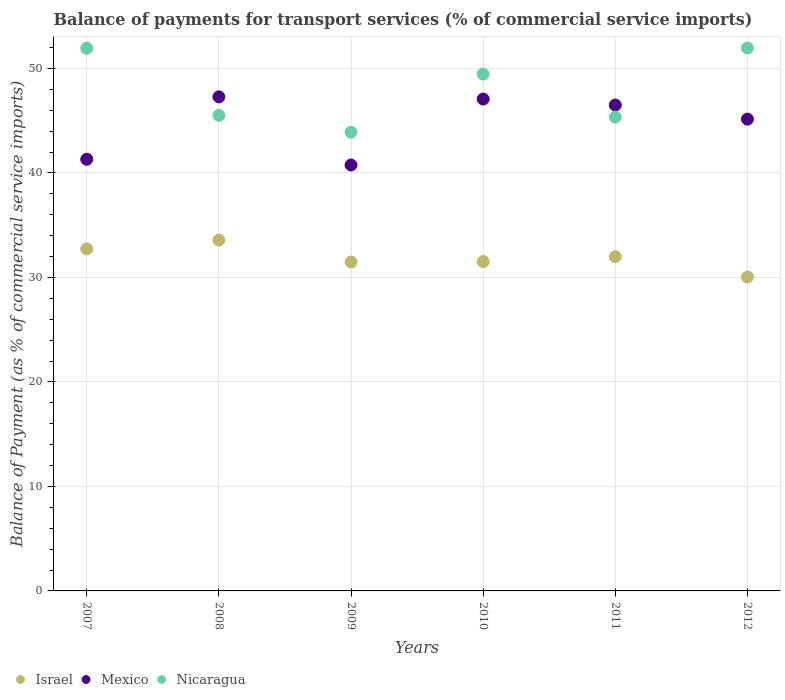What is the balance of payments for transport services in Nicaragua in 2008?
Give a very brief answer. 45.51. Across all years, what is the maximum balance of payments for transport services in Nicaragua?
Keep it short and to the point. 51.96. Across all years, what is the minimum balance of payments for transport services in Mexico?
Your answer should be very brief. 40.76. What is the total balance of payments for transport services in Nicaragua in the graph?
Offer a very short reply. 288.12. What is the difference between the balance of payments for transport services in Nicaragua in 2008 and that in 2012?
Give a very brief answer. -6.45. What is the difference between the balance of payments for transport services in Nicaragua in 2009 and the balance of payments for transport services in Israel in 2010?
Offer a terse response. 12.38. What is the average balance of payments for transport services in Nicaragua per year?
Your answer should be very brief. 48.02. In the year 2008, what is the difference between the balance of payments for transport services in Israel and balance of payments for transport services in Mexico?
Your answer should be compact. -13.71. What is the ratio of the balance of payments for transport services in Mexico in 2011 to that in 2012?
Offer a terse response. 1.03. Is the balance of payments for transport services in Mexico in 2007 less than that in 2012?
Your answer should be very brief. Yes. What is the difference between the highest and the second highest balance of payments for transport services in Nicaragua?
Make the answer very short. 0.03. What is the difference between the highest and the lowest balance of payments for transport services in Israel?
Make the answer very short. 3.53. Is it the case that in every year, the sum of the balance of payments for transport services in Israel and balance of payments for transport services in Mexico  is greater than the balance of payments for transport services in Nicaragua?
Offer a very short reply. Yes. Does the balance of payments for transport services in Nicaragua monotonically increase over the years?
Your response must be concise. No. Is the balance of payments for transport services in Mexico strictly greater than the balance of payments for transport services in Nicaragua over the years?
Make the answer very short. No. Is the balance of payments for transport services in Mexico strictly less than the balance of payments for transport services in Israel over the years?
Offer a terse response. No. How many dotlines are there?
Offer a terse response. 3. How many years are there in the graph?
Keep it short and to the point. 6. Where does the legend appear in the graph?
Offer a very short reply. Bottom left. What is the title of the graph?
Offer a very short reply. Balance of payments for transport services (% of commercial service imports). What is the label or title of the X-axis?
Offer a very short reply. Years. What is the label or title of the Y-axis?
Your response must be concise. Balance of Payment (as % of commercial service imports). What is the Balance of Payment (as % of commercial service imports) in Israel in 2007?
Provide a short and direct response. 32.74. What is the Balance of Payment (as % of commercial service imports) of Mexico in 2007?
Offer a terse response. 41.31. What is the Balance of Payment (as % of commercial service imports) of Nicaragua in 2007?
Your answer should be very brief. 51.93. What is the Balance of Payment (as % of commercial service imports) in Israel in 2008?
Provide a short and direct response. 33.58. What is the Balance of Payment (as % of commercial service imports) in Mexico in 2008?
Offer a terse response. 47.29. What is the Balance of Payment (as % of commercial service imports) of Nicaragua in 2008?
Make the answer very short. 45.51. What is the Balance of Payment (as % of commercial service imports) of Israel in 2009?
Your answer should be very brief. 31.48. What is the Balance of Payment (as % of commercial service imports) of Mexico in 2009?
Your answer should be very brief. 40.76. What is the Balance of Payment (as % of commercial service imports) in Nicaragua in 2009?
Offer a terse response. 43.9. What is the Balance of Payment (as % of commercial service imports) of Israel in 2010?
Keep it short and to the point. 31.52. What is the Balance of Payment (as % of commercial service imports) of Mexico in 2010?
Provide a succinct answer. 47.08. What is the Balance of Payment (as % of commercial service imports) in Nicaragua in 2010?
Offer a very short reply. 49.46. What is the Balance of Payment (as % of commercial service imports) in Israel in 2011?
Your response must be concise. 31.99. What is the Balance of Payment (as % of commercial service imports) of Mexico in 2011?
Keep it short and to the point. 46.5. What is the Balance of Payment (as % of commercial service imports) in Nicaragua in 2011?
Give a very brief answer. 45.35. What is the Balance of Payment (as % of commercial service imports) in Israel in 2012?
Make the answer very short. 30.04. What is the Balance of Payment (as % of commercial service imports) of Mexico in 2012?
Your answer should be very brief. 45.15. What is the Balance of Payment (as % of commercial service imports) of Nicaragua in 2012?
Ensure brevity in your answer.  51.96. Across all years, what is the maximum Balance of Payment (as % of commercial service imports) in Israel?
Provide a short and direct response. 33.58. Across all years, what is the maximum Balance of Payment (as % of commercial service imports) in Mexico?
Give a very brief answer. 47.29. Across all years, what is the maximum Balance of Payment (as % of commercial service imports) in Nicaragua?
Ensure brevity in your answer.  51.96. Across all years, what is the minimum Balance of Payment (as % of commercial service imports) in Israel?
Your answer should be very brief. 30.04. Across all years, what is the minimum Balance of Payment (as % of commercial service imports) of Mexico?
Your answer should be very brief. 40.76. Across all years, what is the minimum Balance of Payment (as % of commercial service imports) in Nicaragua?
Your answer should be compact. 43.9. What is the total Balance of Payment (as % of commercial service imports) of Israel in the graph?
Keep it short and to the point. 191.35. What is the total Balance of Payment (as % of commercial service imports) of Mexico in the graph?
Offer a very short reply. 268.1. What is the total Balance of Payment (as % of commercial service imports) of Nicaragua in the graph?
Provide a short and direct response. 288.12. What is the difference between the Balance of Payment (as % of commercial service imports) of Israel in 2007 and that in 2008?
Provide a short and direct response. -0.84. What is the difference between the Balance of Payment (as % of commercial service imports) of Mexico in 2007 and that in 2008?
Make the answer very short. -5.98. What is the difference between the Balance of Payment (as % of commercial service imports) in Nicaragua in 2007 and that in 2008?
Provide a short and direct response. 6.42. What is the difference between the Balance of Payment (as % of commercial service imports) of Israel in 2007 and that in 2009?
Offer a terse response. 1.26. What is the difference between the Balance of Payment (as % of commercial service imports) of Mexico in 2007 and that in 2009?
Offer a very short reply. 0.55. What is the difference between the Balance of Payment (as % of commercial service imports) in Nicaragua in 2007 and that in 2009?
Your answer should be very brief. 8.03. What is the difference between the Balance of Payment (as % of commercial service imports) in Israel in 2007 and that in 2010?
Provide a short and direct response. 1.22. What is the difference between the Balance of Payment (as % of commercial service imports) in Mexico in 2007 and that in 2010?
Your answer should be compact. -5.76. What is the difference between the Balance of Payment (as % of commercial service imports) of Nicaragua in 2007 and that in 2010?
Provide a short and direct response. 2.47. What is the difference between the Balance of Payment (as % of commercial service imports) of Israel in 2007 and that in 2011?
Make the answer very short. 0.75. What is the difference between the Balance of Payment (as % of commercial service imports) of Mexico in 2007 and that in 2011?
Offer a terse response. -5.19. What is the difference between the Balance of Payment (as % of commercial service imports) of Nicaragua in 2007 and that in 2011?
Give a very brief answer. 6.58. What is the difference between the Balance of Payment (as % of commercial service imports) of Israel in 2007 and that in 2012?
Offer a very short reply. 2.69. What is the difference between the Balance of Payment (as % of commercial service imports) of Mexico in 2007 and that in 2012?
Ensure brevity in your answer.  -3.84. What is the difference between the Balance of Payment (as % of commercial service imports) of Nicaragua in 2007 and that in 2012?
Make the answer very short. -0.03. What is the difference between the Balance of Payment (as % of commercial service imports) of Israel in 2008 and that in 2009?
Your answer should be very brief. 2.1. What is the difference between the Balance of Payment (as % of commercial service imports) of Mexico in 2008 and that in 2009?
Give a very brief answer. 6.52. What is the difference between the Balance of Payment (as % of commercial service imports) of Nicaragua in 2008 and that in 2009?
Ensure brevity in your answer.  1.62. What is the difference between the Balance of Payment (as % of commercial service imports) in Israel in 2008 and that in 2010?
Provide a succinct answer. 2.06. What is the difference between the Balance of Payment (as % of commercial service imports) in Mexico in 2008 and that in 2010?
Offer a very short reply. 0.21. What is the difference between the Balance of Payment (as % of commercial service imports) in Nicaragua in 2008 and that in 2010?
Your answer should be very brief. -3.95. What is the difference between the Balance of Payment (as % of commercial service imports) of Israel in 2008 and that in 2011?
Offer a very short reply. 1.59. What is the difference between the Balance of Payment (as % of commercial service imports) of Mexico in 2008 and that in 2011?
Give a very brief answer. 0.78. What is the difference between the Balance of Payment (as % of commercial service imports) of Nicaragua in 2008 and that in 2011?
Ensure brevity in your answer.  0.16. What is the difference between the Balance of Payment (as % of commercial service imports) in Israel in 2008 and that in 2012?
Your answer should be very brief. 3.53. What is the difference between the Balance of Payment (as % of commercial service imports) of Mexico in 2008 and that in 2012?
Your answer should be compact. 2.13. What is the difference between the Balance of Payment (as % of commercial service imports) in Nicaragua in 2008 and that in 2012?
Your answer should be very brief. -6.45. What is the difference between the Balance of Payment (as % of commercial service imports) of Israel in 2009 and that in 2010?
Your response must be concise. -0.04. What is the difference between the Balance of Payment (as % of commercial service imports) in Mexico in 2009 and that in 2010?
Your response must be concise. -6.31. What is the difference between the Balance of Payment (as % of commercial service imports) in Nicaragua in 2009 and that in 2010?
Offer a terse response. -5.57. What is the difference between the Balance of Payment (as % of commercial service imports) in Israel in 2009 and that in 2011?
Keep it short and to the point. -0.51. What is the difference between the Balance of Payment (as % of commercial service imports) in Mexico in 2009 and that in 2011?
Offer a very short reply. -5.74. What is the difference between the Balance of Payment (as % of commercial service imports) in Nicaragua in 2009 and that in 2011?
Your response must be concise. -1.45. What is the difference between the Balance of Payment (as % of commercial service imports) in Israel in 2009 and that in 2012?
Offer a terse response. 1.43. What is the difference between the Balance of Payment (as % of commercial service imports) of Mexico in 2009 and that in 2012?
Make the answer very short. -4.39. What is the difference between the Balance of Payment (as % of commercial service imports) of Nicaragua in 2009 and that in 2012?
Your answer should be compact. -8.06. What is the difference between the Balance of Payment (as % of commercial service imports) of Israel in 2010 and that in 2011?
Your answer should be very brief. -0.47. What is the difference between the Balance of Payment (as % of commercial service imports) in Mexico in 2010 and that in 2011?
Ensure brevity in your answer.  0.57. What is the difference between the Balance of Payment (as % of commercial service imports) of Nicaragua in 2010 and that in 2011?
Your answer should be compact. 4.11. What is the difference between the Balance of Payment (as % of commercial service imports) of Israel in 2010 and that in 2012?
Your response must be concise. 1.48. What is the difference between the Balance of Payment (as % of commercial service imports) in Mexico in 2010 and that in 2012?
Your answer should be very brief. 1.92. What is the difference between the Balance of Payment (as % of commercial service imports) in Nicaragua in 2010 and that in 2012?
Make the answer very short. -2.5. What is the difference between the Balance of Payment (as % of commercial service imports) of Israel in 2011 and that in 2012?
Keep it short and to the point. 1.95. What is the difference between the Balance of Payment (as % of commercial service imports) of Mexico in 2011 and that in 2012?
Provide a short and direct response. 1.35. What is the difference between the Balance of Payment (as % of commercial service imports) in Nicaragua in 2011 and that in 2012?
Your answer should be compact. -6.61. What is the difference between the Balance of Payment (as % of commercial service imports) of Israel in 2007 and the Balance of Payment (as % of commercial service imports) of Mexico in 2008?
Your answer should be compact. -14.55. What is the difference between the Balance of Payment (as % of commercial service imports) of Israel in 2007 and the Balance of Payment (as % of commercial service imports) of Nicaragua in 2008?
Offer a very short reply. -12.77. What is the difference between the Balance of Payment (as % of commercial service imports) of Mexico in 2007 and the Balance of Payment (as % of commercial service imports) of Nicaragua in 2008?
Your response must be concise. -4.2. What is the difference between the Balance of Payment (as % of commercial service imports) of Israel in 2007 and the Balance of Payment (as % of commercial service imports) of Mexico in 2009?
Provide a short and direct response. -8.02. What is the difference between the Balance of Payment (as % of commercial service imports) of Israel in 2007 and the Balance of Payment (as % of commercial service imports) of Nicaragua in 2009?
Your answer should be very brief. -11.16. What is the difference between the Balance of Payment (as % of commercial service imports) of Mexico in 2007 and the Balance of Payment (as % of commercial service imports) of Nicaragua in 2009?
Your answer should be very brief. -2.59. What is the difference between the Balance of Payment (as % of commercial service imports) of Israel in 2007 and the Balance of Payment (as % of commercial service imports) of Mexico in 2010?
Offer a terse response. -14.34. What is the difference between the Balance of Payment (as % of commercial service imports) of Israel in 2007 and the Balance of Payment (as % of commercial service imports) of Nicaragua in 2010?
Offer a very short reply. -16.72. What is the difference between the Balance of Payment (as % of commercial service imports) in Mexico in 2007 and the Balance of Payment (as % of commercial service imports) in Nicaragua in 2010?
Provide a succinct answer. -8.15. What is the difference between the Balance of Payment (as % of commercial service imports) of Israel in 2007 and the Balance of Payment (as % of commercial service imports) of Mexico in 2011?
Offer a very short reply. -13.76. What is the difference between the Balance of Payment (as % of commercial service imports) in Israel in 2007 and the Balance of Payment (as % of commercial service imports) in Nicaragua in 2011?
Keep it short and to the point. -12.61. What is the difference between the Balance of Payment (as % of commercial service imports) in Mexico in 2007 and the Balance of Payment (as % of commercial service imports) in Nicaragua in 2011?
Your response must be concise. -4.04. What is the difference between the Balance of Payment (as % of commercial service imports) of Israel in 2007 and the Balance of Payment (as % of commercial service imports) of Mexico in 2012?
Your answer should be compact. -12.41. What is the difference between the Balance of Payment (as % of commercial service imports) of Israel in 2007 and the Balance of Payment (as % of commercial service imports) of Nicaragua in 2012?
Offer a terse response. -19.22. What is the difference between the Balance of Payment (as % of commercial service imports) in Mexico in 2007 and the Balance of Payment (as % of commercial service imports) in Nicaragua in 2012?
Keep it short and to the point. -10.65. What is the difference between the Balance of Payment (as % of commercial service imports) in Israel in 2008 and the Balance of Payment (as % of commercial service imports) in Mexico in 2009?
Offer a very short reply. -7.19. What is the difference between the Balance of Payment (as % of commercial service imports) of Israel in 2008 and the Balance of Payment (as % of commercial service imports) of Nicaragua in 2009?
Offer a very short reply. -10.32. What is the difference between the Balance of Payment (as % of commercial service imports) in Mexico in 2008 and the Balance of Payment (as % of commercial service imports) in Nicaragua in 2009?
Offer a very short reply. 3.39. What is the difference between the Balance of Payment (as % of commercial service imports) in Israel in 2008 and the Balance of Payment (as % of commercial service imports) in Mexico in 2010?
Ensure brevity in your answer.  -13.5. What is the difference between the Balance of Payment (as % of commercial service imports) of Israel in 2008 and the Balance of Payment (as % of commercial service imports) of Nicaragua in 2010?
Provide a short and direct response. -15.89. What is the difference between the Balance of Payment (as % of commercial service imports) of Mexico in 2008 and the Balance of Payment (as % of commercial service imports) of Nicaragua in 2010?
Keep it short and to the point. -2.18. What is the difference between the Balance of Payment (as % of commercial service imports) of Israel in 2008 and the Balance of Payment (as % of commercial service imports) of Mexico in 2011?
Offer a very short reply. -12.93. What is the difference between the Balance of Payment (as % of commercial service imports) in Israel in 2008 and the Balance of Payment (as % of commercial service imports) in Nicaragua in 2011?
Your answer should be compact. -11.77. What is the difference between the Balance of Payment (as % of commercial service imports) in Mexico in 2008 and the Balance of Payment (as % of commercial service imports) in Nicaragua in 2011?
Provide a short and direct response. 1.94. What is the difference between the Balance of Payment (as % of commercial service imports) of Israel in 2008 and the Balance of Payment (as % of commercial service imports) of Mexico in 2012?
Ensure brevity in your answer.  -11.58. What is the difference between the Balance of Payment (as % of commercial service imports) of Israel in 2008 and the Balance of Payment (as % of commercial service imports) of Nicaragua in 2012?
Provide a succinct answer. -18.38. What is the difference between the Balance of Payment (as % of commercial service imports) of Mexico in 2008 and the Balance of Payment (as % of commercial service imports) of Nicaragua in 2012?
Provide a succinct answer. -4.67. What is the difference between the Balance of Payment (as % of commercial service imports) of Israel in 2009 and the Balance of Payment (as % of commercial service imports) of Mexico in 2010?
Keep it short and to the point. -15.6. What is the difference between the Balance of Payment (as % of commercial service imports) in Israel in 2009 and the Balance of Payment (as % of commercial service imports) in Nicaragua in 2010?
Ensure brevity in your answer.  -17.98. What is the difference between the Balance of Payment (as % of commercial service imports) of Mexico in 2009 and the Balance of Payment (as % of commercial service imports) of Nicaragua in 2010?
Your response must be concise. -8.7. What is the difference between the Balance of Payment (as % of commercial service imports) of Israel in 2009 and the Balance of Payment (as % of commercial service imports) of Mexico in 2011?
Offer a very short reply. -15.02. What is the difference between the Balance of Payment (as % of commercial service imports) in Israel in 2009 and the Balance of Payment (as % of commercial service imports) in Nicaragua in 2011?
Keep it short and to the point. -13.87. What is the difference between the Balance of Payment (as % of commercial service imports) in Mexico in 2009 and the Balance of Payment (as % of commercial service imports) in Nicaragua in 2011?
Provide a short and direct response. -4.59. What is the difference between the Balance of Payment (as % of commercial service imports) of Israel in 2009 and the Balance of Payment (as % of commercial service imports) of Mexico in 2012?
Offer a terse response. -13.67. What is the difference between the Balance of Payment (as % of commercial service imports) in Israel in 2009 and the Balance of Payment (as % of commercial service imports) in Nicaragua in 2012?
Offer a very short reply. -20.48. What is the difference between the Balance of Payment (as % of commercial service imports) of Mexico in 2009 and the Balance of Payment (as % of commercial service imports) of Nicaragua in 2012?
Provide a succinct answer. -11.2. What is the difference between the Balance of Payment (as % of commercial service imports) of Israel in 2010 and the Balance of Payment (as % of commercial service imports) of Mexico in 2011?
Offer a very short reply. -14.98. What is the difference between the Balance of Payment (as % of commercial service imports) of Israel in 2010 and the Balance of Payment (as % of commercial service imports) of Nicaragua in 2011?
Provide a short and direct response. -13.83. What is the difference between the Balance of Payment (as % of commercial service imports) in Mexico in 2010 and the Balance of Payment (as % of commercial service imports) in Nicaragua in 2011?
Make the answer very short. 1.73. What is the difference between the Balance of Payment (as % of commercial service imports) in Israel in 2010 and the Balance of Payment (as % of commercial service imports) in Mexico in 2012?
Give a very brief answer. -13.63. What is the difference between the Balance of Payment (as % of commercial service imports) of Israel in 2010 and the Balance of Payment (as % of commercial service imports) of Nicaragua in 2012?
Make the answer very short. -20.44. What is the difference between the Balance of Payment (as % of commercial service imports) in Mexico in 2010 and the Balance of Payment (as % of commercial service imports) in Nicaragua in 2012?
Your answer should be very brief. -4.88. What is the difference between the Balance of Payment (as % of commercial service imports) in Israel in 2011 and the Balance of Payment (as % of commercial service imports) in Mexico in 2012?
Your answer should be compact. -13.16. What is the difference between the Balance of Payment (as % of commercial service imports) of Israel in 2011 and the Balance of Payment (as % of commercial service imports) of Nicaragua in 2012?
Ensure brevity in your answer.  -19.97. What is the difference between the Balance of Payment (as % of commercial service imports) in Mexico in 2011 and the Balance of Payment (as % of commercial service imports) in Nicaragua in 2012?
Your answer should be very brief. -5.46. What is the average Balance of Payment (as % of commercial service imports) of Israel per year?
Your response must be concise. 31.89. What is the average Balance of Payment (as % of commercial service imports) of Mexico per year?
Provide a succinct answer. 44.68. What is the average Balance of Payment (as % of commercial service imports) of Nicaragua per year?
Make the answer very short. 48.02. In the year 2007, what is the difference between the Balance of Payment (as % of commercial service imports) of Israel and Balance of Payment (as % of commercial service imports) of Mexico?
Your answer should be very brief. -8.57. In the year 2007, what is the difference between the Balance of Payment (as % of commercial service imports) in Israel and Balance of Payment (as % of commercial service imports) in Nicaragua?
Keep it short and to the point. -19.19. In the year 2007, what is the difference between the Balance of Payment (as % of commercial service imports) in Mexico and Balance of Payment (as % of commercial service imports) in Nicaragua?
Offer a very short reply. -10.62. In the year 2008, what is the difference between the Balance of Payment (as % of commercial service imports) in Israel and Balance of Payment (as % of commercial service imports) in Mexico?
Make the answer very short. -13.71. In the year 2008, what is the difference between the Balance of Payment (as % of commercial service imports) of Israel and Balance of Payment (as % of commercial service imports) of Nicaragua?
Keep it short and to the point. -11.94. In the year 2008, what is the difference between the Balance of Payment (as % of commercial service imports) in Mexico and Balance of Payment (as % of commercial service imports) in Nicaragua?
Provide a succinct answer. 1.77. In the year 2009, what is the difference between the Balance of Payment (as % of commercial service imports) of Israel and Balance of Payment (as % of commercial service imports) of Mexico?
Give a very brief answer. -9.28. In the year 2009, what is the difference between the Balance of Payment (as % of commercial service imports) of Israel and Balance of Payment (as % of commercial service imports) of Nicaragua?
Provide a succinct answer. -12.42. In the year 2009, what is the difference between the Balance of Payment (as % of commercial service imports) in Mexico and Balance of Payment (as % of commercial service imports) in Nicaragua?
Offer a very short reply. -3.13. In the year 2010, what is the difference between the Balance of Payment (as % of commercial service imports) of Israel and Balance of Payment (as % of commercial service imports) of Mexico?
Keep it short and to the point. -15.56. In the year 2010, what is the difference between the Balance of Payment (as % of commercial service imports) of Israel and Balance of Payment (as % of commercial service imports) of Nicaragua?
Offer a terse response. -17.94. In the year 2010, what is the difference between the Balance of Payment (as % of commercial service imports) of Mexico and Balance of Payment (as % of commercial service imports) of Nicaragua?
Ensure brevity in your answer.  -2.39. In the year 2011, what is the difference between the Balance of Payment (as % of commercial service imports) of Israel and Balance of Payment (as % of commercial service imports) of Mexico?
Ensure brevity in your answer.  -14.51. In the year 2011, what is the difference between the Balance of Payment (as % of commercial service imports) of Israel and Balance of Payment (as % of commercial service imports) of Nicaragua?
Your response must be concise. -13.36. In the year 2011, what is the difference between the Balance of Payment (as % of commercial service imports) of Mexico and Balance of Payment (as % of commercial service imports) of Nicaragua?
Keep it short and to the point. 1.15. In the year 2012, what is the difference between the Balance of Payment (as % of commercial service imports) of Israel and Balance of Payment (as % of commercial service imports) of Mexico?
Provide a succinct answer. -15.11. In the year 2012, what is the difference between the Balance of Payment (as % of commercial service imports) of Israel and Balance of Payment (as % of commercial service imports) of Nicaragua?
Provide a succinct answer. -21.92. In the year 2012, what is the difference between the Balance of Payment (as % of commercial service imports) of Mexico and Balance of Payment (as % of commercial service imports) of Nicaragua?
Make the answer very short. -6.81. What is the ratio of the Balance of Payment (as % of commercial service imports) of Israel in 2007 to that in 2008?
Provide a short and direct response. 0.98. What is the ratio of the Balance of Payment (as % of commercial service imports) of Mexico in 2007 to that in 2008?
Your response must be concise. 0.87. What is the ratio of the Balance of Payment (as % of commercial service imports) of Nicaragua in 2007 to that in 2008?
Give a very brief answer. 1.14. What is the ratio of the Balance of Payment (as % of commercial service imports) in Mexico in 2007 to that in 2009?
Keep it short and to the point. 1.01. What is the ratio of the Balance of Payment (as % of commercial service imports) of Nicaragua in 2007 to that in 2009?
Offer a terse response. 1.18. What is the ratio of the Balance of Payment (as % of commercial service imports) of Israel in 2007 to that in 2010?
Offer a terse response. 1.04. What is the ratio of the Balance of Payment (as % of commercial service imports) of Mexico in 2007 to that in 2010?
Offer a very short reply. 0.88. What is the ratio of the Balance of Payment (as % of commercial service imports) in Nicaragua in 2007 to that in 2010?
Ensure brevity in your answer.  1.05. What is the ratio of the Balance of Payment (as % of commercial service imports) in Israel in 2007 to that in 2011?
Ensure brevity in your answer.  1.02. What is the ratio of the Balance of Payment (as % of commercial service imports) of Mexico in 2007 to that in 2011?
Your answer should be very brief. 0.89. What is the ratio of the Balance of Payment (as % of commercial service imports) of Nicaragua in 2007 to that in 2011?
Your answer should be compact. 1.15. What is the ratio of the Balance of Payment (as % of commercial service imports) of Israel in 2007 to that in 2012?
Offer a terse response. 1.09. What is the ratio of the Balance of Payment (as % of commercial service imports) in Mexico in 2007 to that in 2012?
Your answer should be very brief. 0.91. What is the ratio of the Balance of Payment (as % of commercial service imports) of Israel in 2008 to that in 2009?
Your answer should be very brief. 1.07. What is the ratio of the Balance of Payment (as % of commercial service imports) in Mexico in 2008 to that in 2009?
Your answer should be very brief. 1.16. What is the ratio of the Balance of Payment (as % of commercial service imports) of Nicaragua in 2008 to that in 2009?
Your answer should be very brief. 1.04. What is the ratio of the Balance of Payment (as % of commercial service imports) in Israel in 2008 to that in 2010?
Give a very brief answer. 1.07. What is the ratio of the Balance of Payment (as % of commercial service imports) of Nicaragua in 2008 to that in 2010?
Offer a very short reply. 0.92. What is the ratio of the Balance of Payment (as % of commercial service imports) in Israel in 2008 to that in 2011?
Your answer should be compact. 1.05. What is the ratio of the Balance of Payment (as % of commercial service imports) in Mexico in 2008 to that in 2011?
Offer a terse response. 1.02. What is the ratio of the Balance of Payment (as % of commercial service imports) of Israel in 2008 to that in 2012?
Provide a short and direct response. 1.12. What is the ratio of the Balance of Payment (as % of commercial service imports) in Mexico in 2008 to that in 2012?
Your answer should be compact. 1.05. What is the ratio of the Balance of Payment (as % of commercial service imports) of Nicaragua in 2008 to that in 2012?
Offer a terse response. 0.88. What is the ratio of the Balance of Payment (as % of commercial service imports) in Mexico in 2009 to that in 2010?
Your answer should be compact. 0.87. What is the ratio of the Balance of Payment (as % of commercial service imports) of Nicaragua in 2009 to that in 2010?
Provide a short and direct response. 0.89. What is the ratio of the Balance of Payment (as % of commercial service imports) in Mexico in 2009 to that in 2011?
Your answer should be very brief. 0.88. What is the ratio of the Balance of Payment (as % of commercial service imports) in Nicaragua in 2009 to that in 2011?
Ensure brevity in your answer.  0.97. What is the ratio of the Balance of Payment (as % of commercial service imports) of Israel in 2009 to that in 2012?
Ensure brevity in your answer.  1.05. What is the ratio of the Balance of Payment (as % of commercial service imports) of Mexico in 2009 to that in 2012?
Offer a very short reply. 0.9. What is the ratio of the Balance of Payment (as % of commercial service imports) of Nicaragua in 2009 to that in 2012?
Provide a short and direct response. 0.84. What is the ratio of the Balance of Payment (as % of commercial service imports) in Mexico in 2010 to that in 2011?
Provide a short and direct response. 1.01. What is the ratio of the Balance of Payment (as % of commercial service imports) of Nicaragua in 2010 to that in 2011?
Make the answer very short. 1.09. What is the ratio of the Balance of Payment (as % of commercial service imports) of Israel in 2010 to that in 2012?
Your answer should be compact. 1.05. What is the ratio of the Balance of Payment (as % of commercial service imports) of Mexico in 2010 to that in 2012?
Keep it short and to the point. 1.04. What is the ratio of the Balance of Payment (as % of commercial service imports) of Nicaragua in 2010 to that in 2012?
Provide a succinct answer. 0.95. What is the ratio of the Balance of Payment (as % of commercial service imports) of Israel in 2011 to that in 2012?
Your answer should be compact. 1.06. What is the ratio of the Balance of Payment (as % of commercial service imports) in Mexico in 2011 to that in 2012?
Provide a short and direct response. 1.03. What is the ratio of the Balance of Payment (as % of commercial service imports) in Nicaragua in 2011 to that in 2012?
Keep it short and to the point. 0.87. What is the difference between the highest and the second highest Balance of Payment (as % of commercial service imports) of Israel?
Your answer should be very brief. 0.84. What is the difference between the highest and the second highest Balance of Payment (as % of commercial service imports) of Mexico?
Make the answer very short. 0.21. What is the difference between the highest and the second highest Balance of Payment (as % of commercial service imports) of Nicaragua?
Make the answer very short. 0.03. What is the difference between the highest and the lowest Balance of Payment (as % of commercial service imports) in Israel?
Keep it short and to the point. 3.53. What is the difference between the highest and the lowest Balance of Payment (as % of commercial service imports) of Mexico?
Keep it short and to the point. 6.52. What is the difference between the highest and the lowest Balance of Payment (as % of commercial service imports) in Nicaragua?
Ensure brevity in your answer.  8.06. 